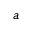Convert formula to latex. <formula><loc_0><loc_0><loc_500><loc_500>^ { a }</formula> 